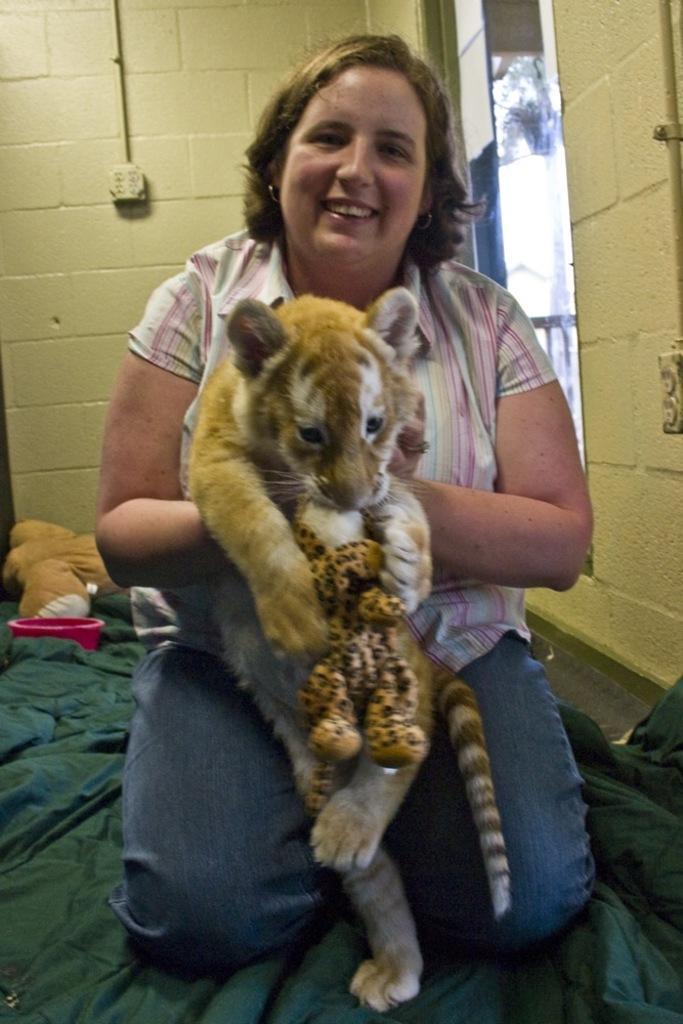Describe this image in one or two sentences. In the picture we can see a woman sitting on the knee on the green carpet and she is smiling and holding a tiger cub and in the background, we can see a bowl which is pink in color and to the wall we can see a switch and a pipe to it. 